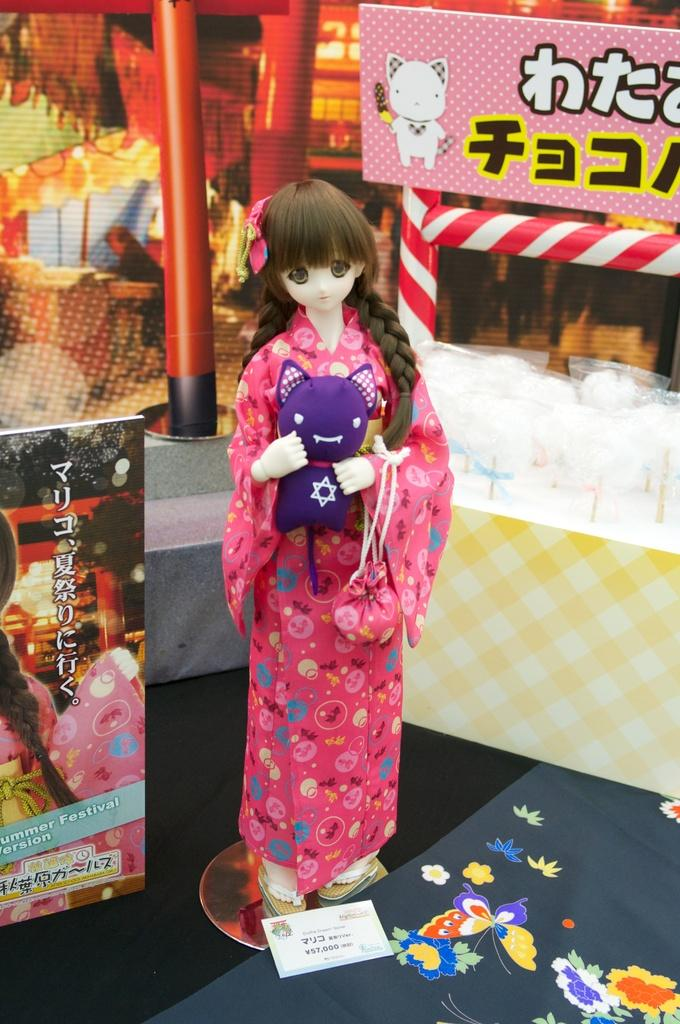What type of toy is in the image? There is a Barbie doll in the image. How is the Barbie doll presented in the image? The Barbie doll is on a display. What is the reaction of the Barbie doll to the ocean in the image? There is no ocean present in the image, so it is not possible to determine the Barbie doll's reaction to it. 